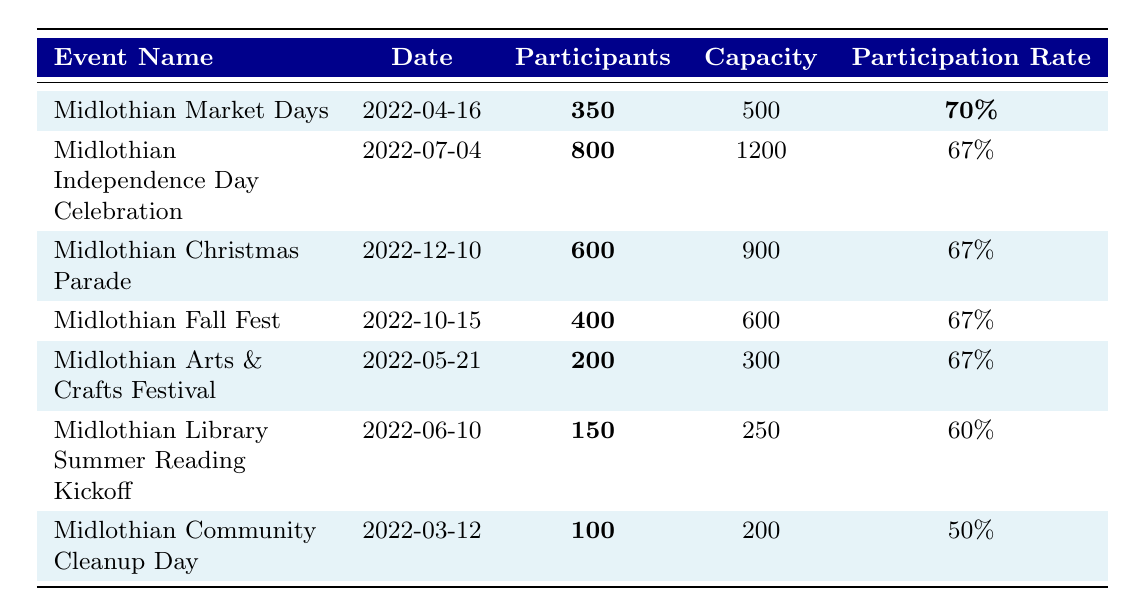What was the highest participation rate among the events? The highest participation rate listed in the table is for "Midlothian Market Days," which has a participation rate of 70%.
Answer: 70% How many participants were there in the "Midlothian Independence Day Celebration"? The table shows that there were 800 participants in this event.
Answer: 800 What is the total capacity of all events listed? By summing the capacities: 500 + 1200 + 900 + 600 + 300 + 250 + 200 = 3950, the total capacity is 3950.
Answer: 3950 Which event had the lowest number of participants? "Midlothian Community Cleanup Day" had the lowest with only 100 participants.
Answer: 100 What percentage of events had a participation rate of 67%? There are four events, three of which (Independence Day Celebration, Christmas Parade, Fall Fest, and Arts & Crafts Festival) had a participation rate of 67%. Thus, the percentage is (3/7)*100 = 42.86%, so approximately 43%.
Answer: 43% What was the average participation rate for all events? Calculating the average: (70% + 67% + 67% + 67% + 67% + 60% + 50%) / 7 = 64.14%. The average participation rate is approximately 64%.
Answer: 64% Did any event have a participation rate below 60%? Yes, "Midlothian Library Summer Reading Kickoff" had a participation rate of 60%, which is not below, and "Midlothian Community Cleanup Day" had a participation rate of 50%, which is below.
Answer: Yes How many more participants were at the "Midlothian Christmas Parade" compared to the "Midlothian Community Cleanup Day"? The difference in participants is calculated as 600 (Christmas Parade) - 100 (Community Cleanup Day) = 500.
Answer: 500 Which event had a higher capacity, "Midlothian Market Days" or "Midlothian Library Summer Reading Kickoff"? "Midlothian Market Days" has a capacity of 500 while "Midlothian Library Summer Reading Kickoff" has a capacity of 250. Thus, Market Days had a higher capacity.
Answer: Midlothian Market Days How many events had a participation rate of less than 70%? There are six events with participation rates of less than 70%: Independence Day Celebration, Christmas Parade, Fall Fest, Arts & Crafts Festival, Library Summer Reading Kickoff, and Community Cleanup Day.
Answer: 6 What fraction of participants attended "Midlothian Fall Fest" compared to "Midlothian Independence Day Celebration"? The fraction is calculated as 400 (Fall Fest) / 800 (Independence) = 1/2.
Answer: 1/2 